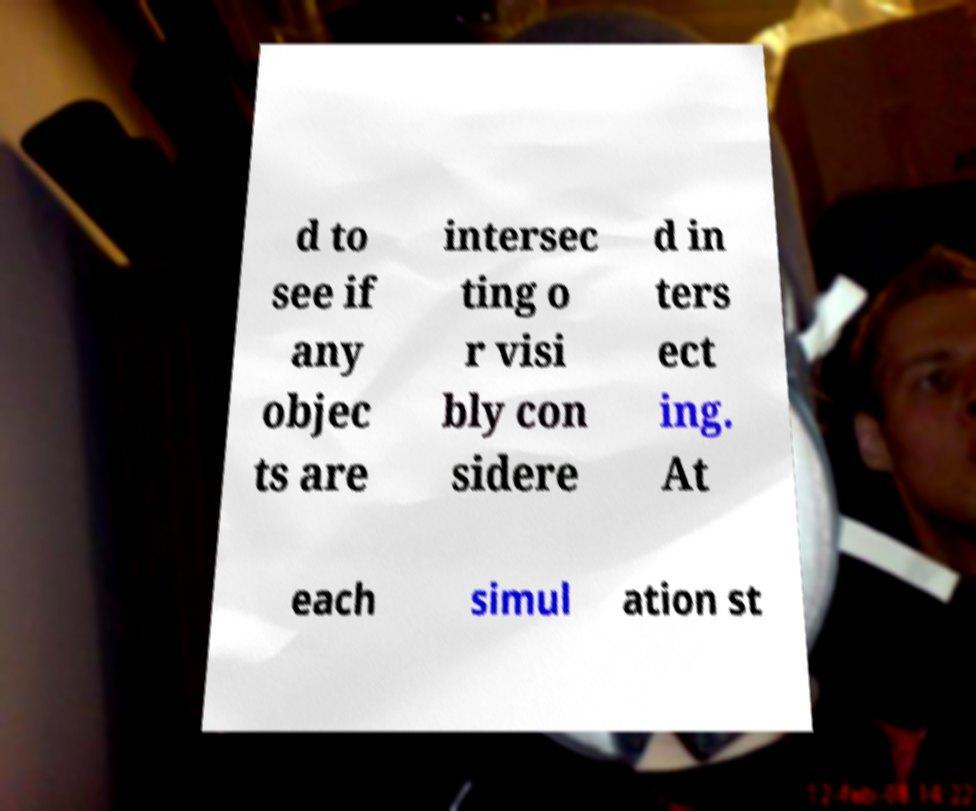Please identify and transcribe the text found in this image. d to see if any objec ts are intersec ting o r visi bly con sidere d in ters ect ing. At each simul ation st 